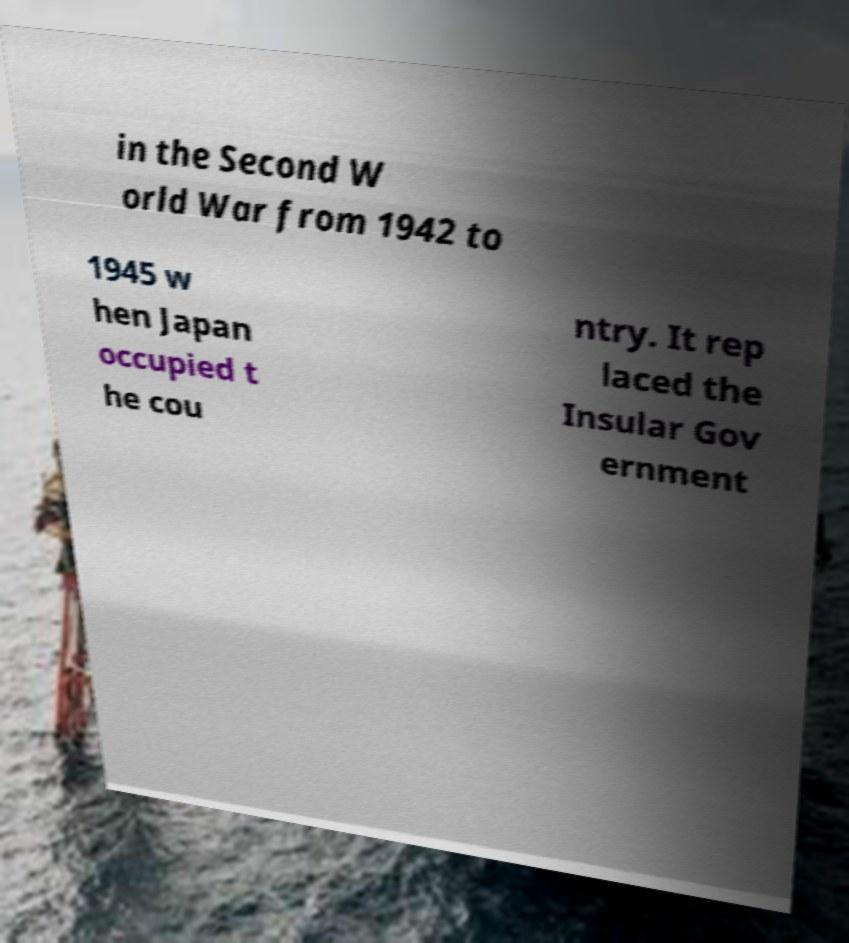What messages or text are displayed in this image? I need them in a readable, typed format. in the Second W orld War from 1942 to 1945 w hen Japan occupied t he cou ntry. It rep laced the Insular Gov ernment 